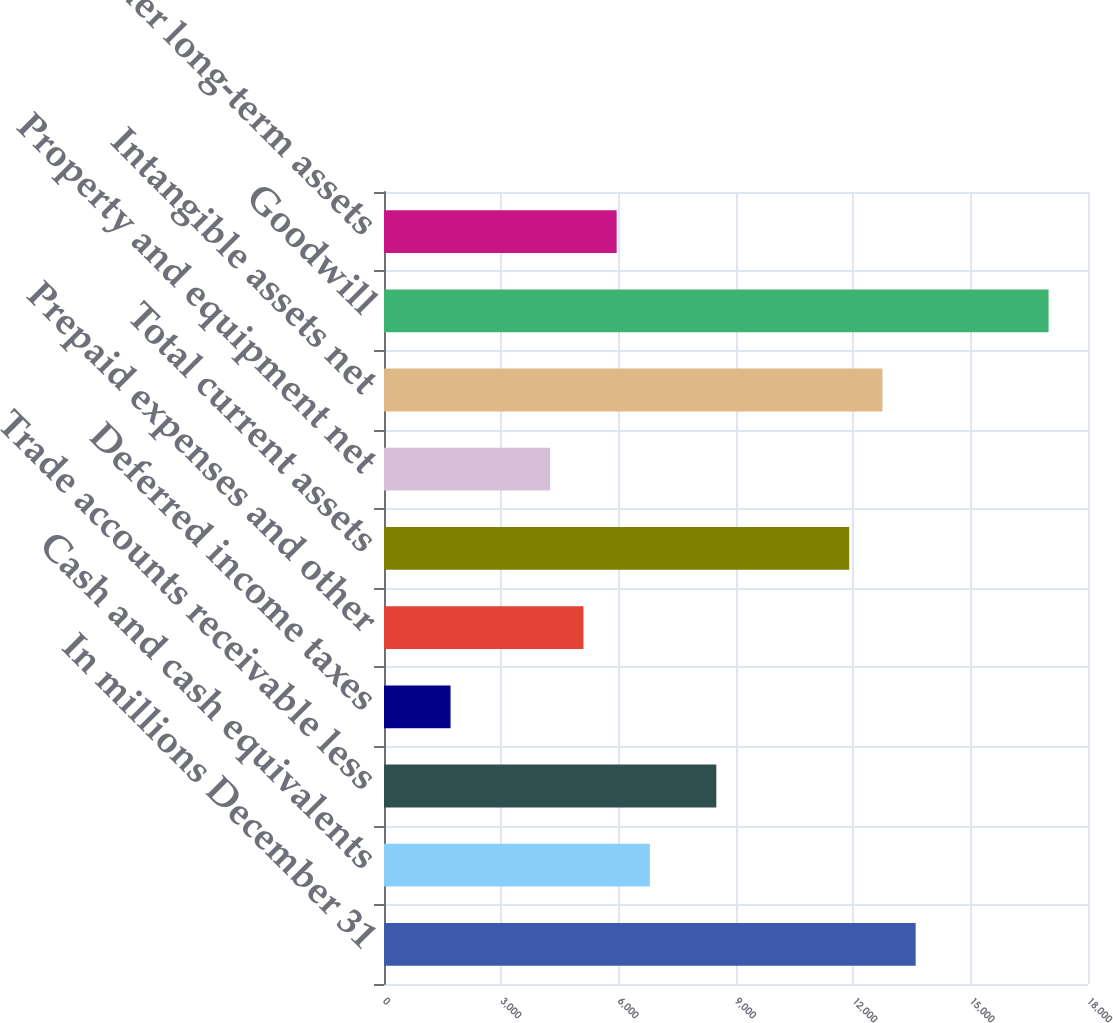<chart> <loc_0><loc_0><loc_500><loc_500><bar_chart><fcel>In millions December 31<fcel>Cash and cash equivalents<fcel>Trade accounts receivable less<fcel>Deferred income taxes<fcel>Prepaid expenses and other<fcel>Total current assets<fcel>Property and equipment net<fcel>Intangible assets net<fcel>Goodwill<fcel>Other long-term assets<nl><fcel>13594<fcel>6798<fcel>8497<fcel>1701<fcel>5099<fcel>11895<fcel>4249.5<fcel>12744.5<fcel>16992<fcel>5948.5<nl></chart> 